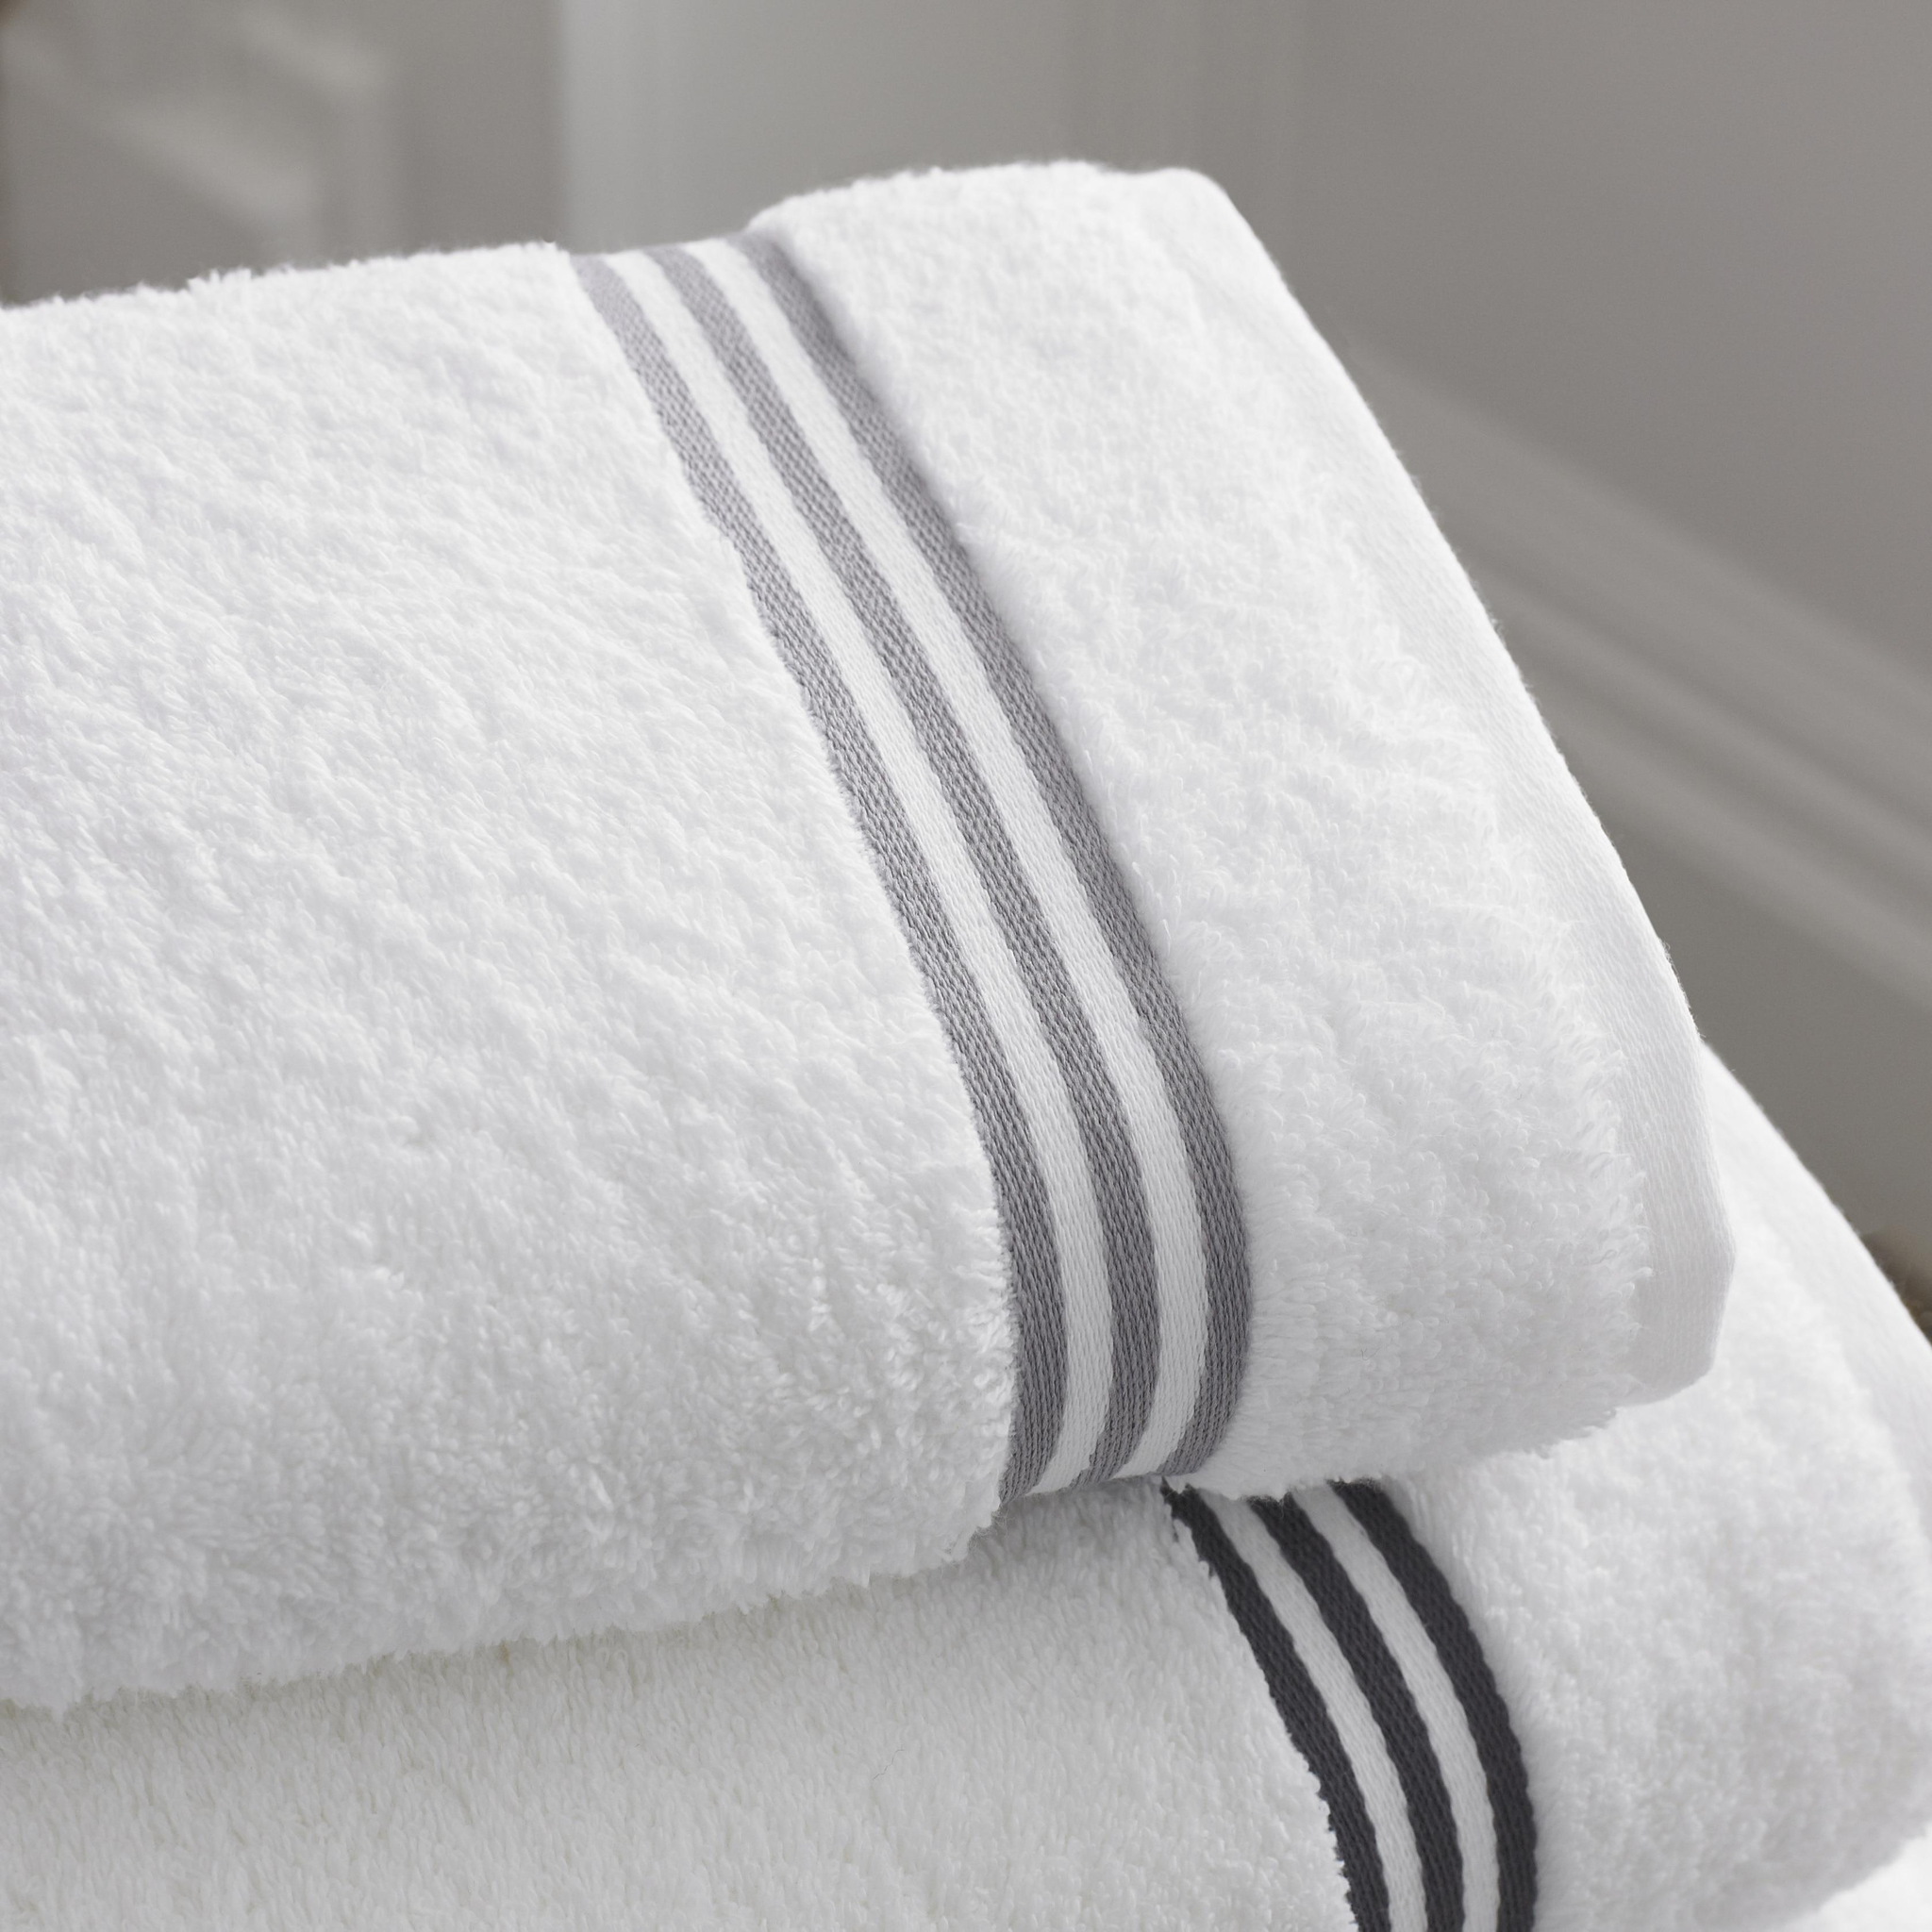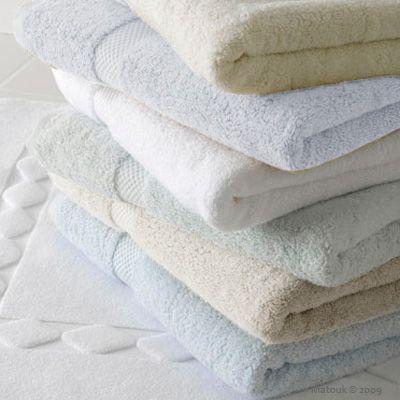The first image is the image on the left, the second image is the image on the right. For the images shown, is this caption "One image includes gray and white towels with an all-over pattern." true? Answer yes or no. No. 